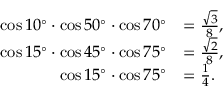Convert formula to latex. <formula><loc_0><loc_0><loc_500><loc_500>{ \begin{array} { r l } { \cos 1 0 ^ { \circ } \cdot \cos 5 0 ^ { \circ } \cdot \cos 7 0 ^ { \circ } } & { = { \frac { \sqrt { 3 } } { 8 } } , } \\ { \cos 1 5 ^ { \circ } \cdot \cos 4 5 ^ { \circ } \cdot \cos 7 5 ^ { \circ } } & { = { \frac { \sqrt { 2 } } { 8 } } , } \\ { \cos 1 5 ^ { \circ } \cdot \cos 7 5 ^ { \circ } } & { = { \frac { 1 } { 4 } } . } \end{array} }</formula> 